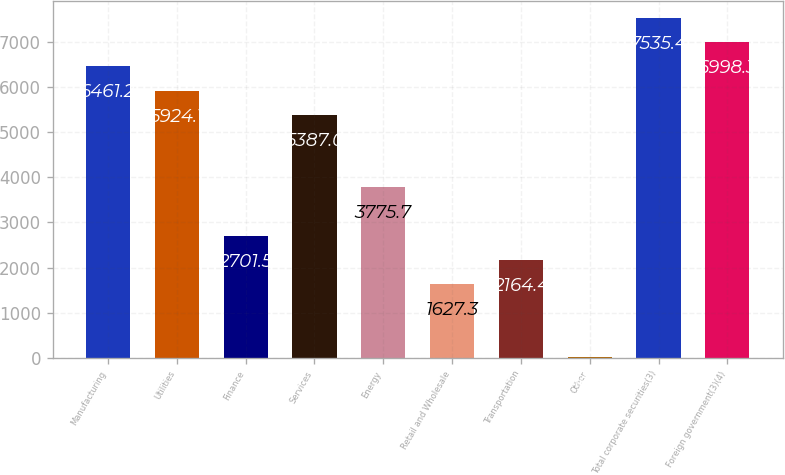Convert chart. <chart><loc_0><loc_0><loc_500><loc_500><bar_chart><fcel>Manufacturing<fcel>Utilities<fcel>Finance<fcel>Services<fcel>Energy<fcel>Retail and Wholesale<fcel>Transportation<fcel>Other<fcel>Total corporate securities(3)<fcel>Foreign government(3)(4)<nl><fcel>6461.2<fcel>5924.1<fcel>2701.5<fcel>5387<fcel>3775.7<fcel>1627.3<fcel>2164.4<fcel>16<fcel>7535.4<fcel>6998.3<nl></chart> 